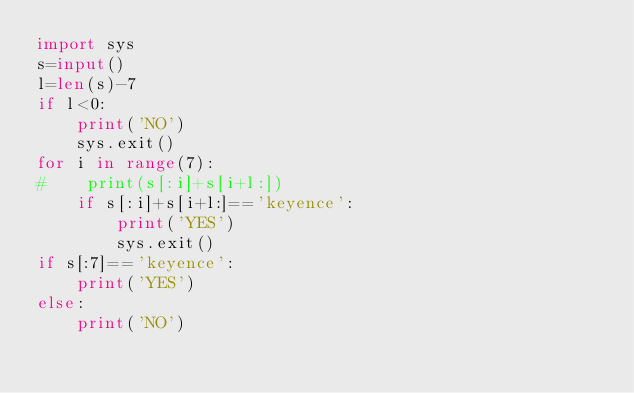<code> <loc_0><loc_0><loc_500><loc_500><_Python_>import sys
s=input()
l=len(s)-7
if l<0:
    print('NO')
    sys.exit()
for i in range(7):
#    print(s[:i]+s[i+l:])
    if s[:i]+s[i+l:]=='keyence':
        print('YES')
        sys.exit()
if s[:7]=='keyence':
    print('YES')
else:
    print('NO')</code> 